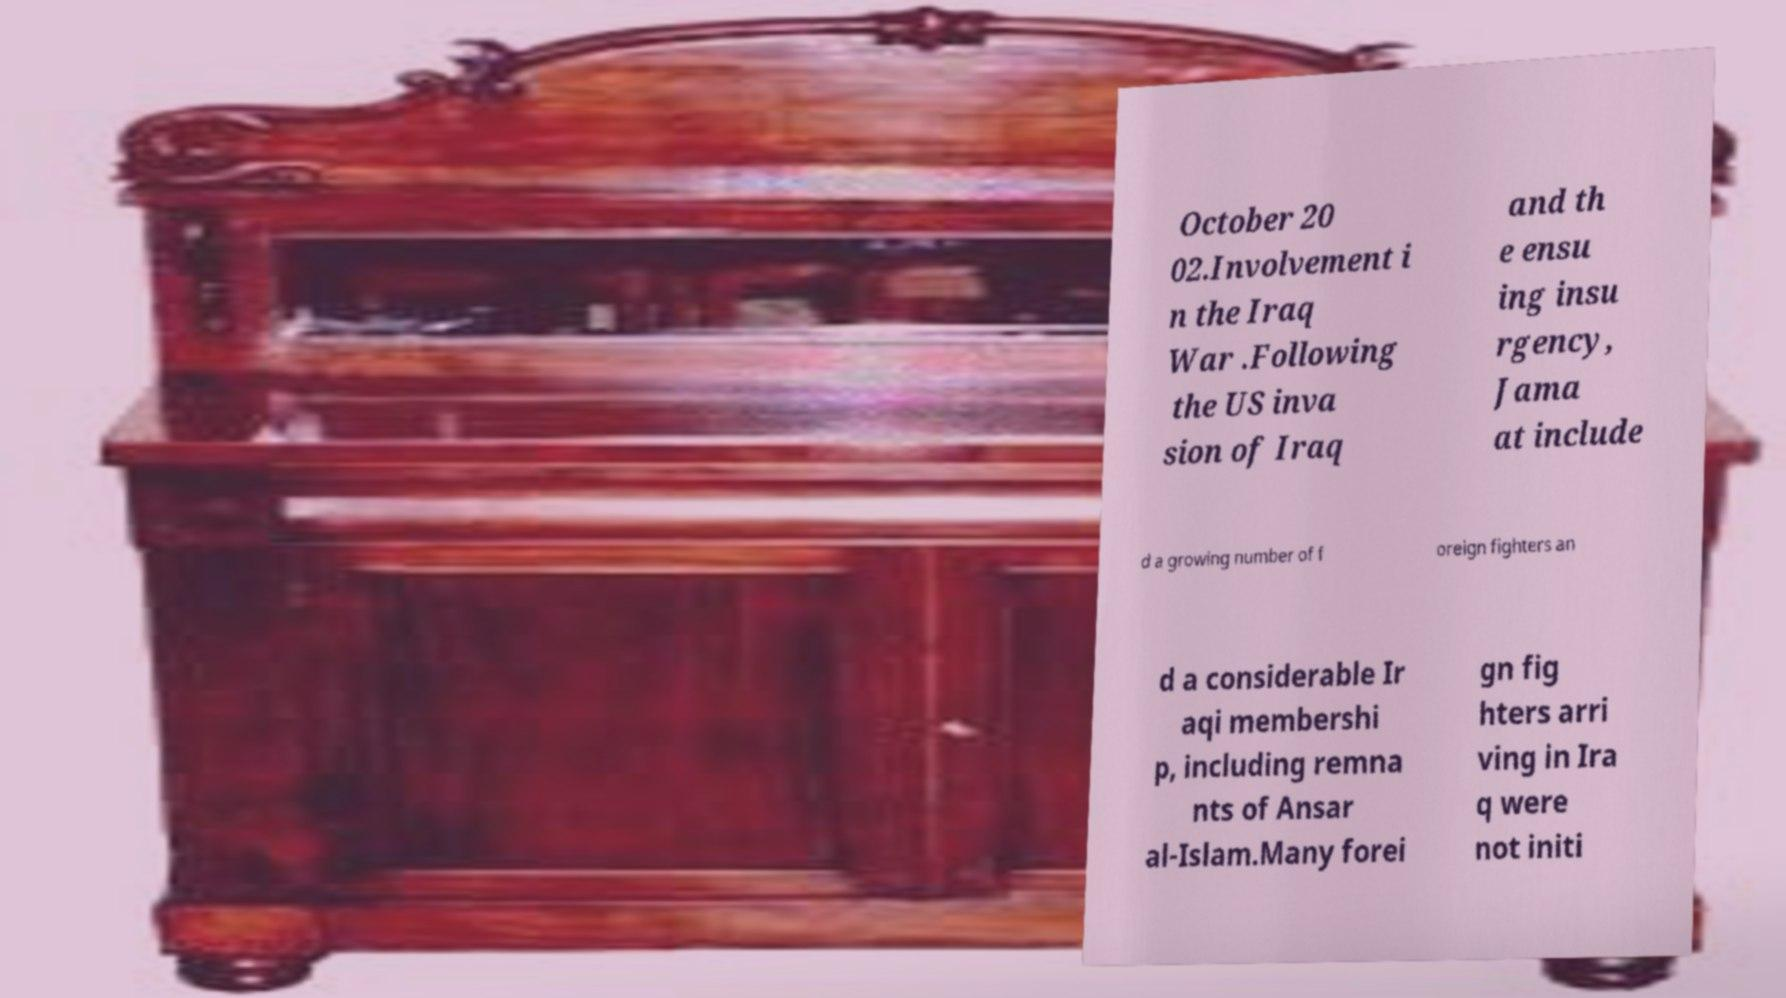There's text embedded in this image that I need extracted. Can you transcribe it verbatim? October 20 02.Involvement i n the Iraq War .Following the US inva sion of Iraq and th e ensu ing insu rgency, Jama at include d a growing number of f oreign fighters an d a considerable Ir aqi membershi p, including remna nts of Ansar al-Islam.Many forei gn fig hters arri ving in Ira q were not initi 